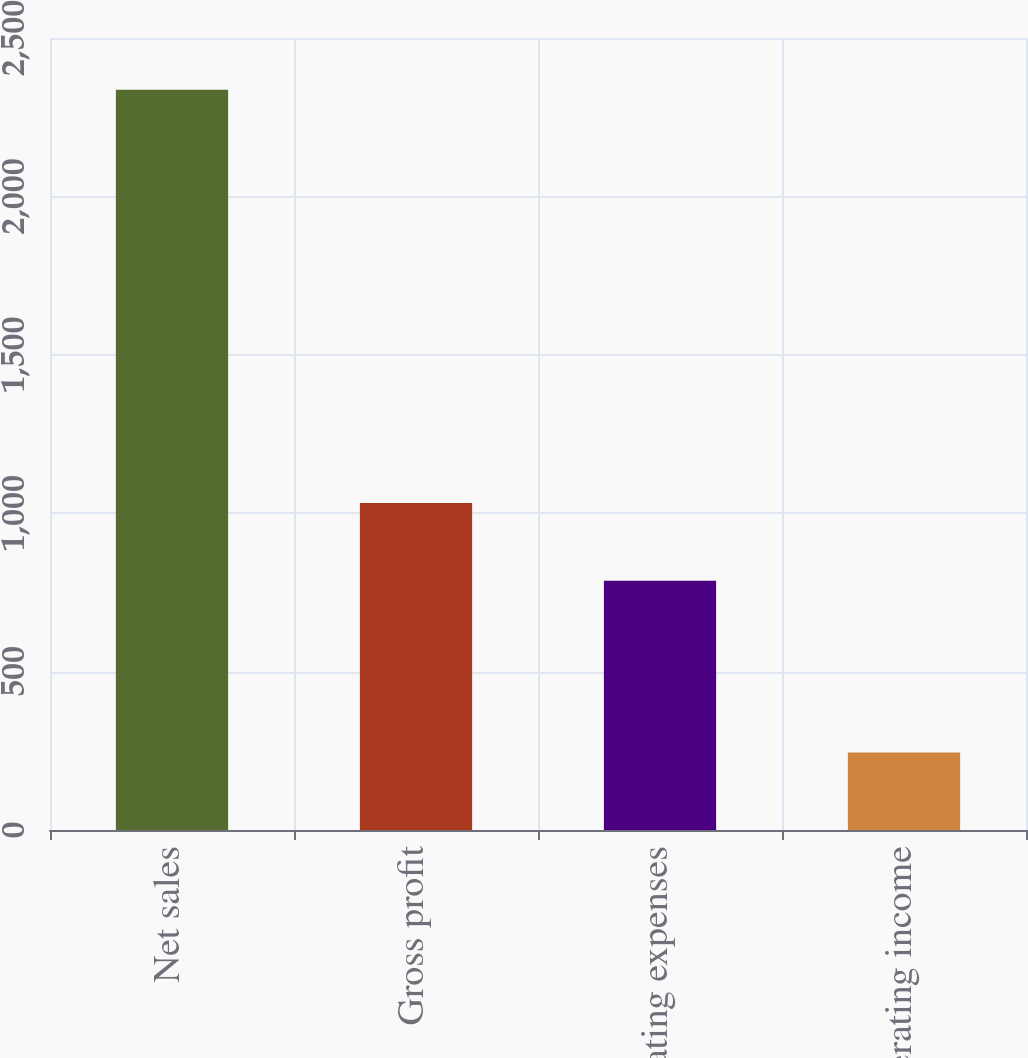<chart> <loc_0><loc_0><loc_500><loc_500><bar_chart><fcel>Net sales<fcel>Gross profit<fcel>Operating expenses<fcel>Operating income<nl><fcel>2337<fcel>1032<fcel>787<fcel>245<nl></chart> 